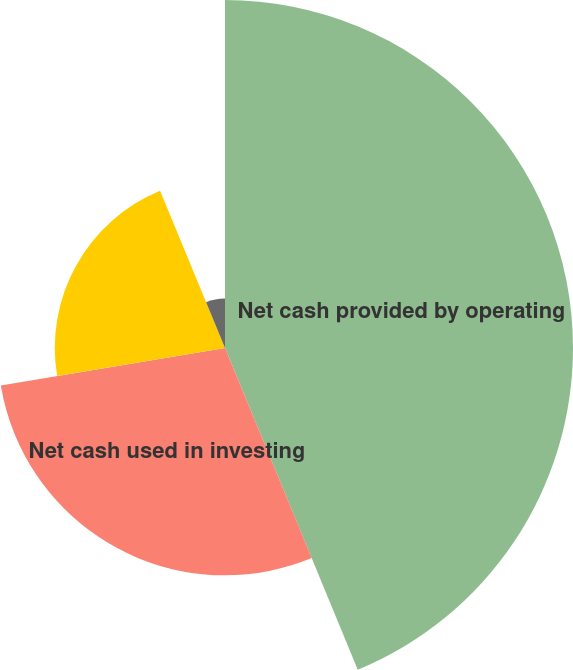Convert chart. <chart><loc_0><loc_0><loc_500><loc_500><pie_chart><fcel>Net cash provided by operating<fcel>Net cash used in investing<fcel>Net cash used in financing<fcel>Decrease in cash and cash<nl><fcel>43.77%<fcel>28.59%<fcel>21.41%<fcel>6.23%<nl></chart> 